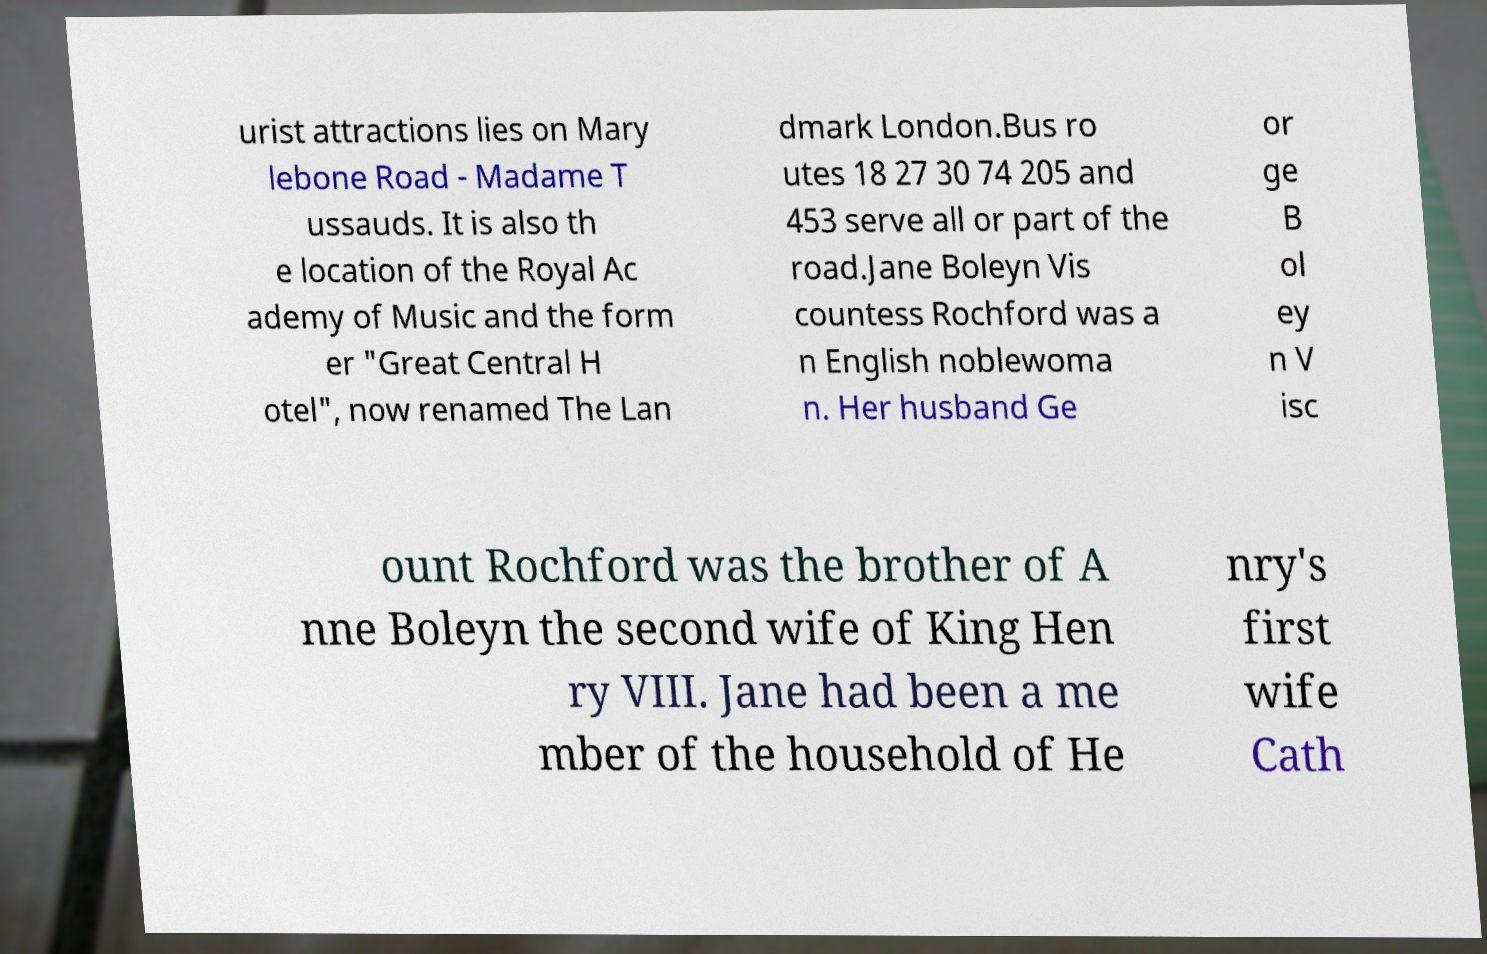There's text embedded in this image that I need extracted. Can you transcribe it verbatim? urist attractions lies on Mary lebone Road - Madame T ussauds. It is also th e location of the Royal Ac ademy of Music and the form er "Great Central H otel", now renamed The Lan dmark London.Bus ro utes 18 27 30 74 205 and 453 serve all or part of the road.Jane Boleyn Vis countess Rochford was a n English noblewoma n. Her husband Ge or ge B ol ey n V isc ount Rochford was the brother of A nne Boleyn the second wife of King Hen ry VIII. Jane had been a me mber of the household of He nry's first wife Cath 